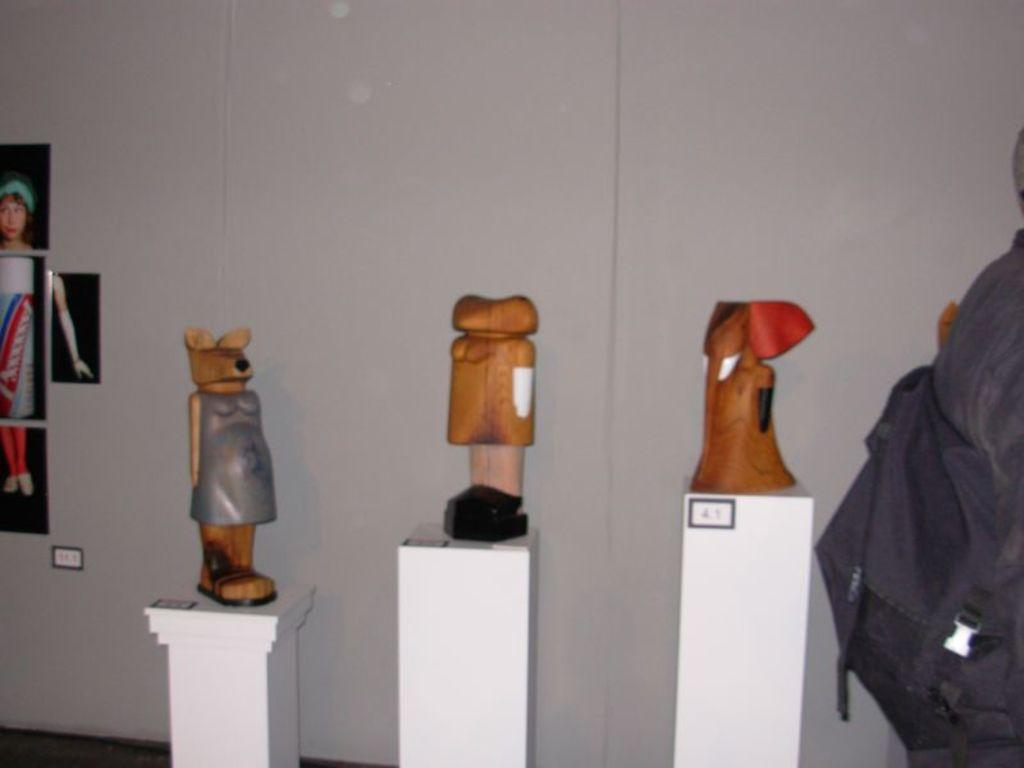What type of objects can be seen in the image? There are toys in the image. What can be seen on the wall in the image? There are photos on the wall in the image. What color is the bag in the image? The bag in the image is black. What is the color of the surface or background in the image? The objects mentioned are on a white surface or background. What type of nut is used to hold the toys together in the image? There is no nut present in the image, and the toys are not held together by any visible means. 